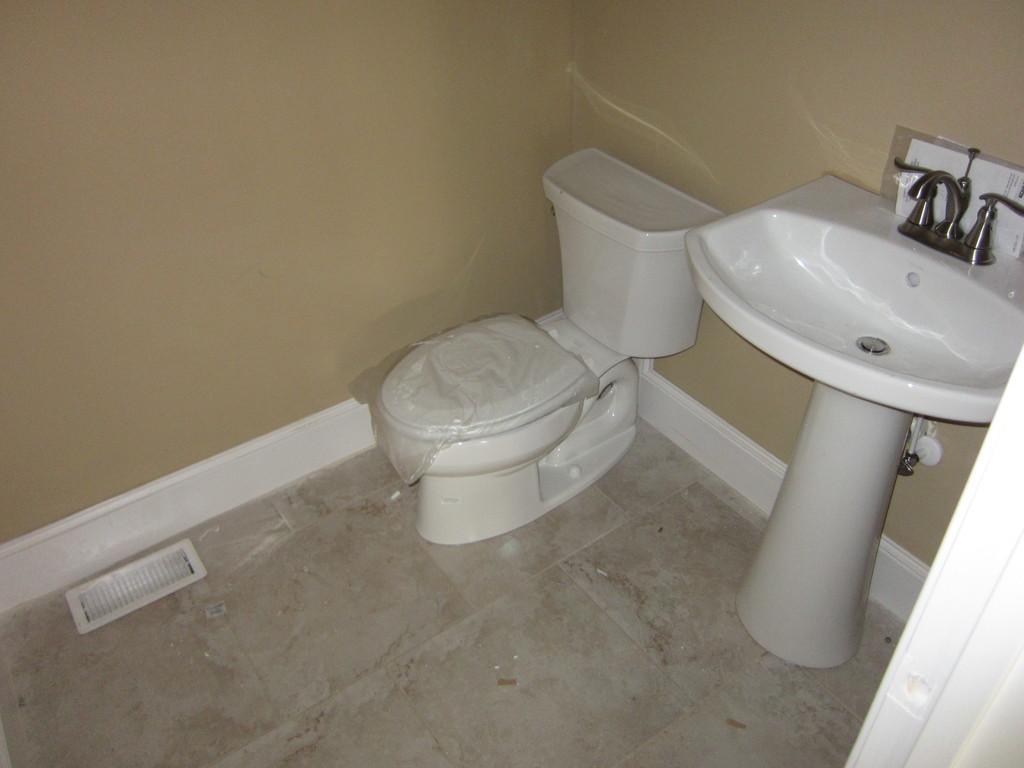How would you summarize this image in a sentence or two? In this image, I can see a toilet bowl, wash basin and a wall. This picture might be taken in a room. 